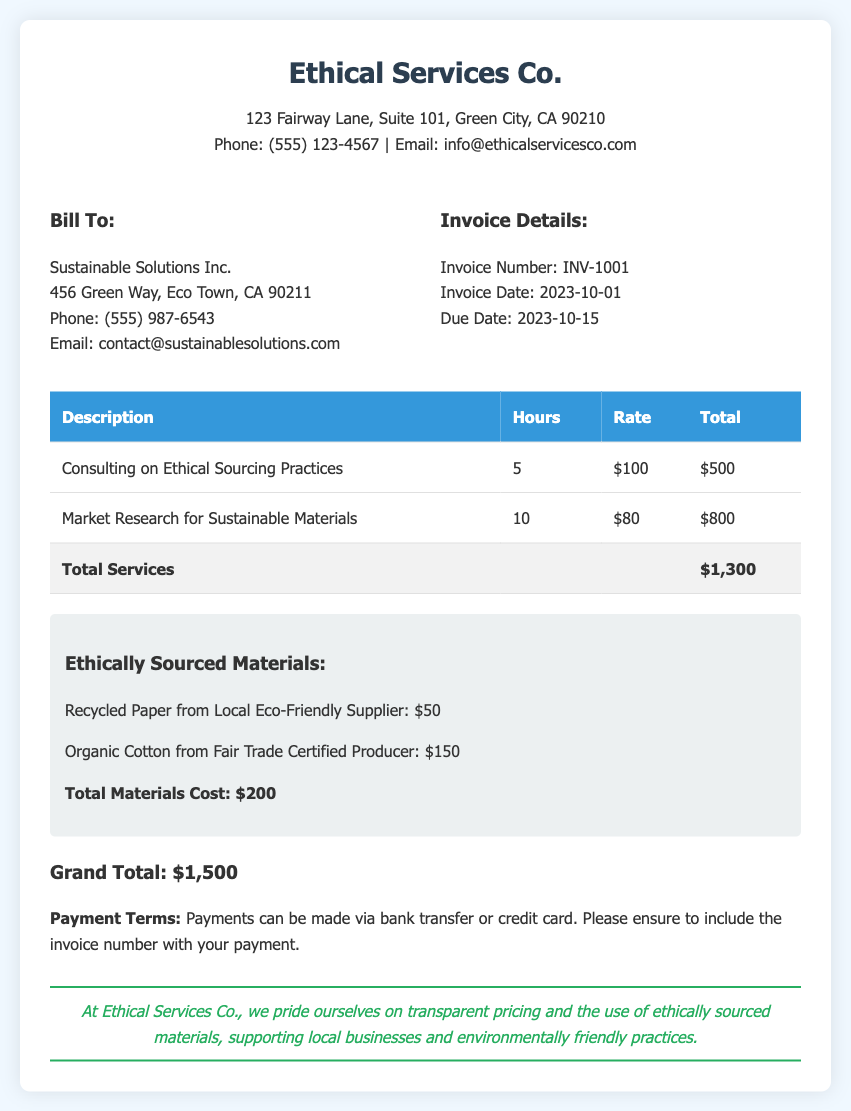What is the invoice number? The invoice number is specified in the invoice details section.
Answer: INV-1001 What is the total cost for services rendered? The total cost for services is summarized in the "Total Services" row of the table.
Answer: $1,300 What is the total cost for ethically sourced materials? The total cost for materials is provided below the materials section.
Answer: $200 What is the due date for the invoice? The due date is indicated within the invoice details section.
Answer: 2023-10-15 How many hours were spent on market research? The hours spent are recorded in the table under the "Hours" column for the respective service.
Answer: 10 What materials are sourced ethically? The materials listed in the "Ethically Sourced Materials" section include specific items.
Answer: Recycled Paper, Organic Cotton What is the grand total of the invoice? The grand total is calculated and presented at the end of the invoice.
Answer: $1,500 What is the company's phone number? The company's contact information section includes the phone number.
Answer: (555) 123-4567 What type of payment is accepted? The payment methods are described in the payment terms section of the invoice.
Answer: Bank transfer or credit card 